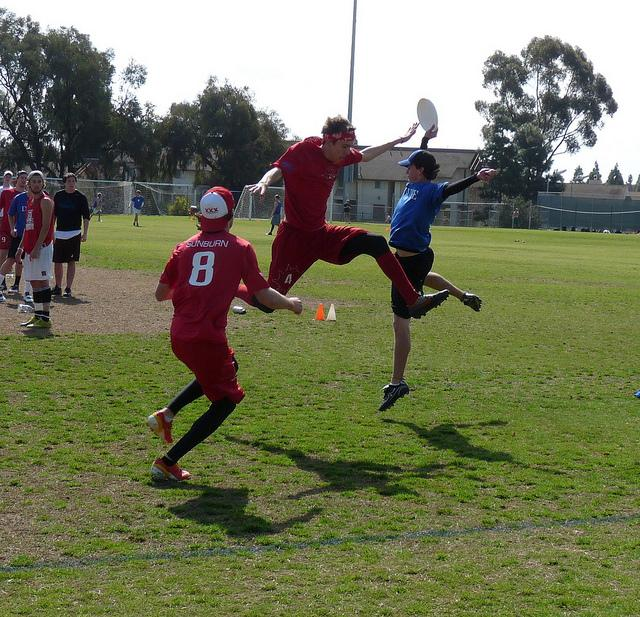What word rhymes with the number on the man's shirt? Please explain your reasoning. hate. The word is hate. 